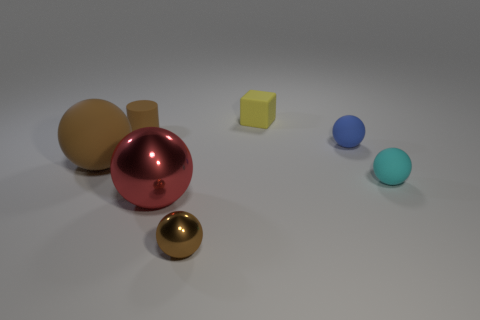Subtract all yellow spheres. Subtract all blue cubes. How many spheres are left? 5 Add 3 tiny cubes. How many objects exist? 10 Subtract all cylinders. How many objects are left? 6 Subtract 0 green balls. How many objects are left? 7 Subtract all small rubber cylinders. Subtract all small brown metal spheres. How many objects are left? 5 Add 1 cubes. How many cubes are left? 2 Add 5 tiny rubber cylinders. How many tiny rubber cylinders exist? 6 